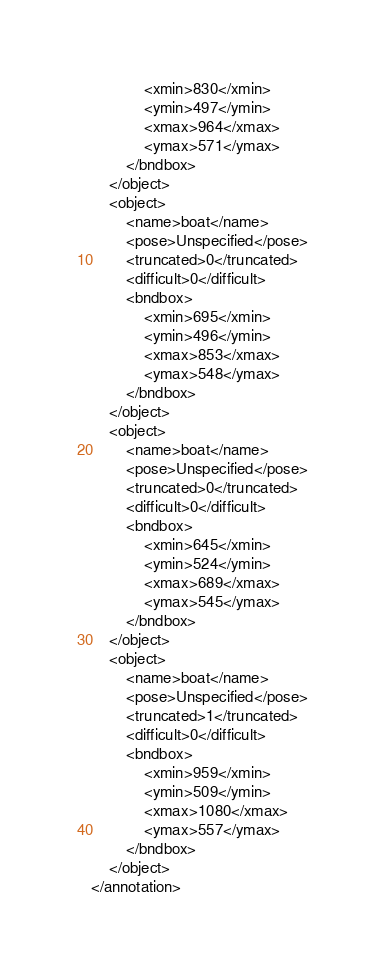Convert code to text. <code><loc_0><loc_0><loc_500><loc_500><_XML_>			<xmin>830</xmin>
			<ymin>497</ymin>
			<xmax>964</xmax>
			<ymax>571</ymax>
		</bndbox>
	</object>
	<object>
		<name>boat</name>
		<pose>Unspecified</pose>
		<truncated>0</truncated>
		<difficult>0</difficult>
		<bndbox>
			<xmin>695</xmin>
			<ymin>496</ymin>
			<xmax>853</xmax>
			<ymax>548</ymax>
		</bndbox>
	</object>
	<object>
		<name>boat</name>
		<pose>Unspecified</pose>
		<truncated>0</truncated>
		<difficult>0</difficult>
		<bndbox>
			<xmin>645</xmin>
			<ymin>524</ymin>
			<xmax>689</xmax>
			<ymax>545</ymax>
		</bndbox>
	</object>
	<object>
		<name>boat</name>
		<pose>Unspecified</pose>
		<truncated>1</truncated>
		<difficult>0</difficult>
		<bndbox>
			<xmin>959</xmin>
			<ymin>509</ymin>
			<xmax>1080</xmax>
			<ymax>557</ymax>
		</bndbox>
	</object>
</annotation>
</code> 